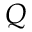<formula> <loc_0><loc_0><loc_500><loc_500>Q</formula> 